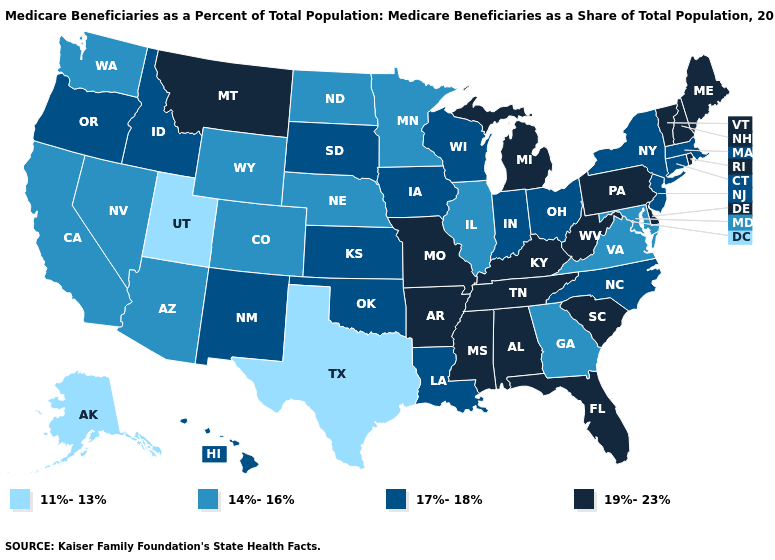Name the states that have a value in the range 17%-18%?
Short answer required. Connecticut, Hawaii, Idaho, Indiana, Iowa, Kansas, Louisiana, Massachusetts, New Jersey, New Mexico, New York, North Carolina, Ohio, Oklahoma, Oregon, South Dakota, Wisconsin. Name the states that have a value in the range 11%-13%?
Give a very brief answer. Alaska, Texas, Utah. What is the highest value in the USA?
Concise answer only. 19%-23%. Which states have the highest value in the USA?
Concise answer only. Alabama, Arkansas, Delaware, Florida, Kentucky, Maine, Michigan, Mississippi, Missouri, Montana, New Hampshire, Pennsylvania, Rhode Island, South Carolina, Tennessee, Vermont, West Virginia. Name the states that have a value in the range 17%-18%?
Be succinct. Connecticut, Hawaii, Idaho, Indiana, Iowa, Kansas, Louisiana, Massachusetts, New Jersey, New Mexico, New York, North Carolina, Ohio, Oklahoma, Oregon, South Dakota, Wisconsin. What is the lowest value in states that border New Jersey?
Concise answer only. 17%-18%. Name the states that have a value in the range 19%-23%?
Write a very short answer. Alabama, Arkansas, Delaware, Florida, Kentucky, Maine, Michigan, Mississippi, Missouri, Montana, New Hampshire, Pennsylvania, Rhode Island, South Carolina, Tennessee, Vermont, West Virginia. How many symbols are there in the legend?
Be succinct. 4. Among the states that border Rhode Island , which have the highest value?
Quick response, please. Connecticut, Massachusetts. What is the lowest value in states that border Wyoming?
Concise answer only. 11%-13%. Name the states that have a value in the range 19%-23%?
Give a very brief answer. Alabama, Arkansas, Delaware, Florida, Kentucky, Maine, Michigan, Mississippi, Missouri, Montana, New Hampshire, Pennsylvania, Rhode Island, South Carolina, Tennessee, Vermont, West Virginia. Does Maine have the highest value in the Northeast?
Write a very short answer. Yes. What is the value of Idaho?
Quick response, please. 17%-18%. Among the states that border Delaware , does Maryland have the lowest value?
Answer briefly. Yes. What is the value of Oregon?
Keep it brief. 17%-18%. 